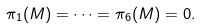Convert formula to latex. <formula><loc_0><loc_0><loc_500><loc_500>\pi _ { 1 } ( M ) = \cdots = \pi _ { 6 } ( M ) = 0 .</formula> 